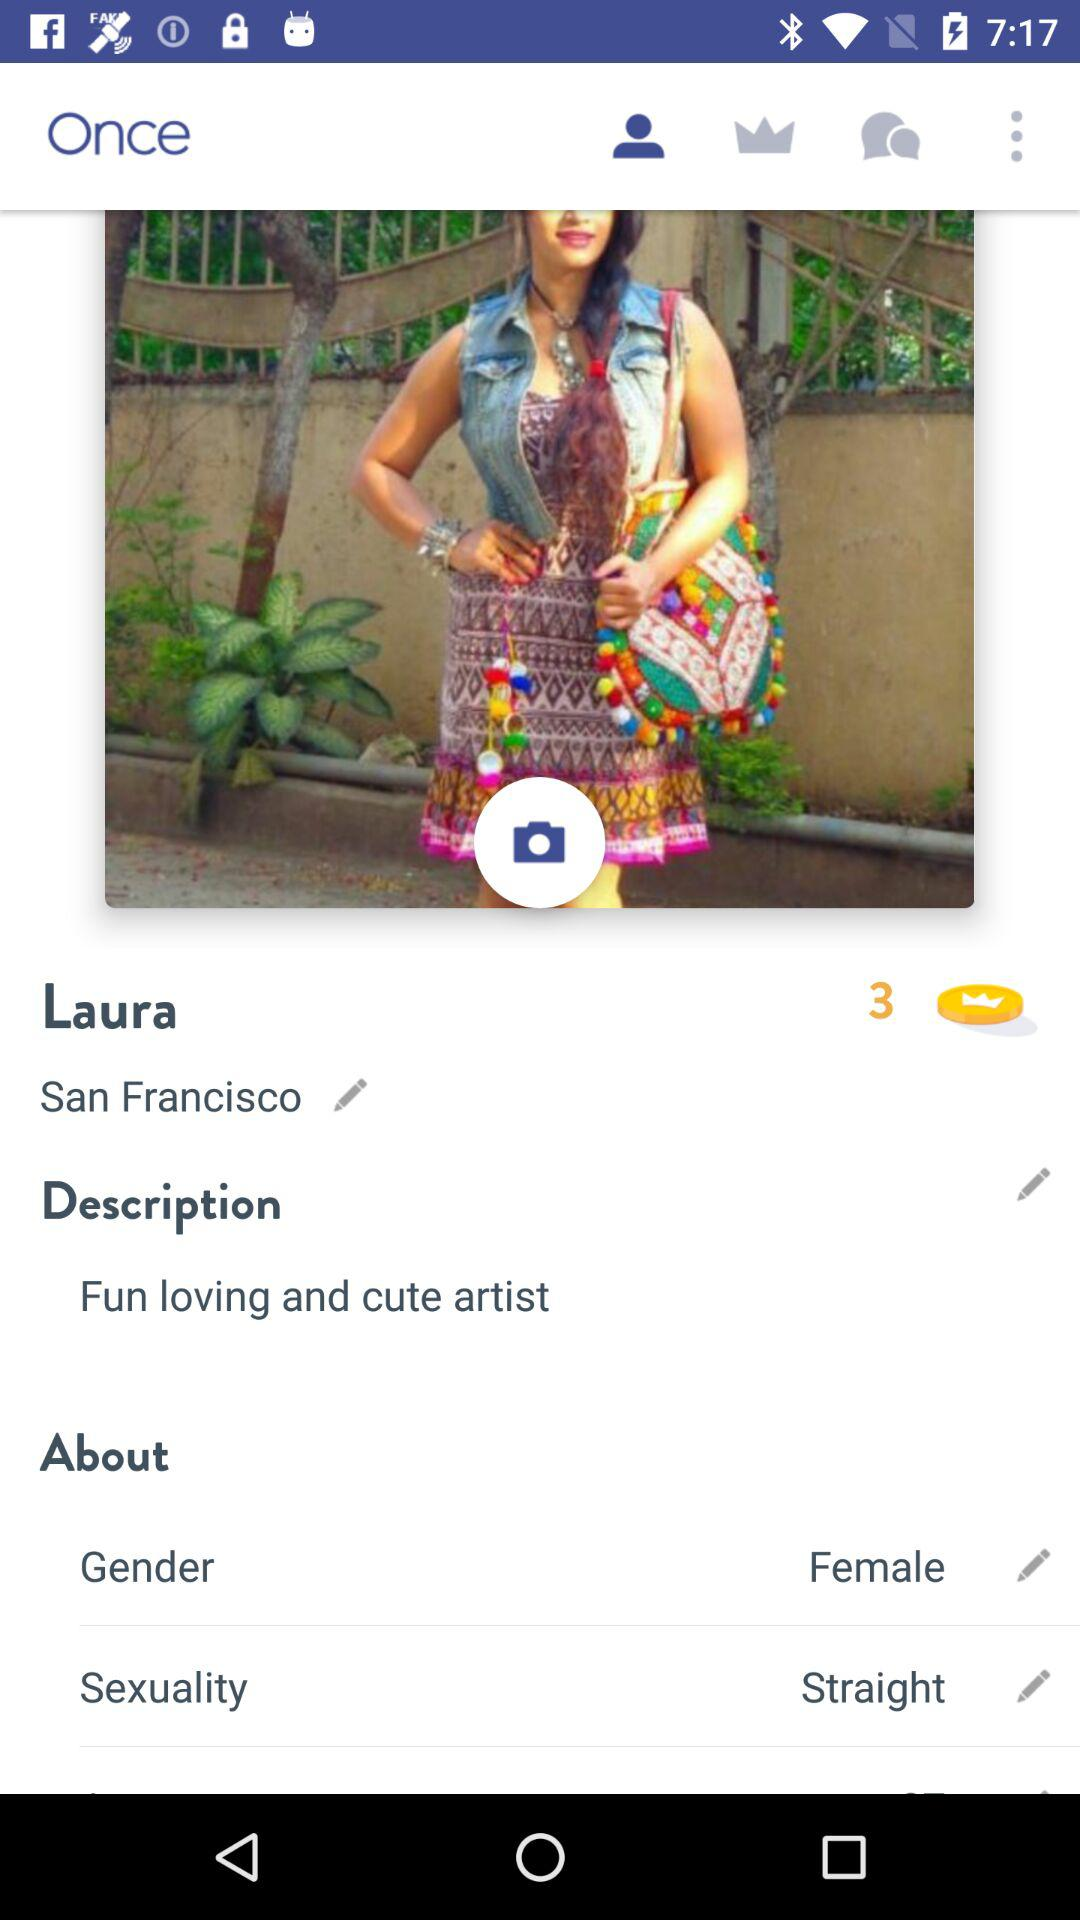What is the gender? The gender is female. 